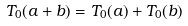Convert formula to latex. <formula><loc_0><loc_0><loc_500><loc_500>T _ { 0 } ( a + b ) = T _ { 0 } ( a ) + T _ { 0 } ( b )</formula> 